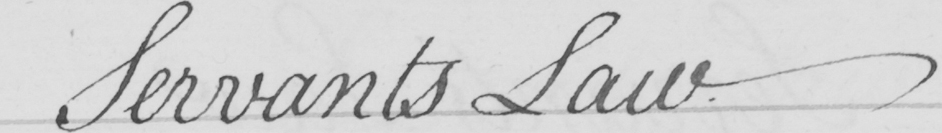What does this handwritten line say? Servants Law 